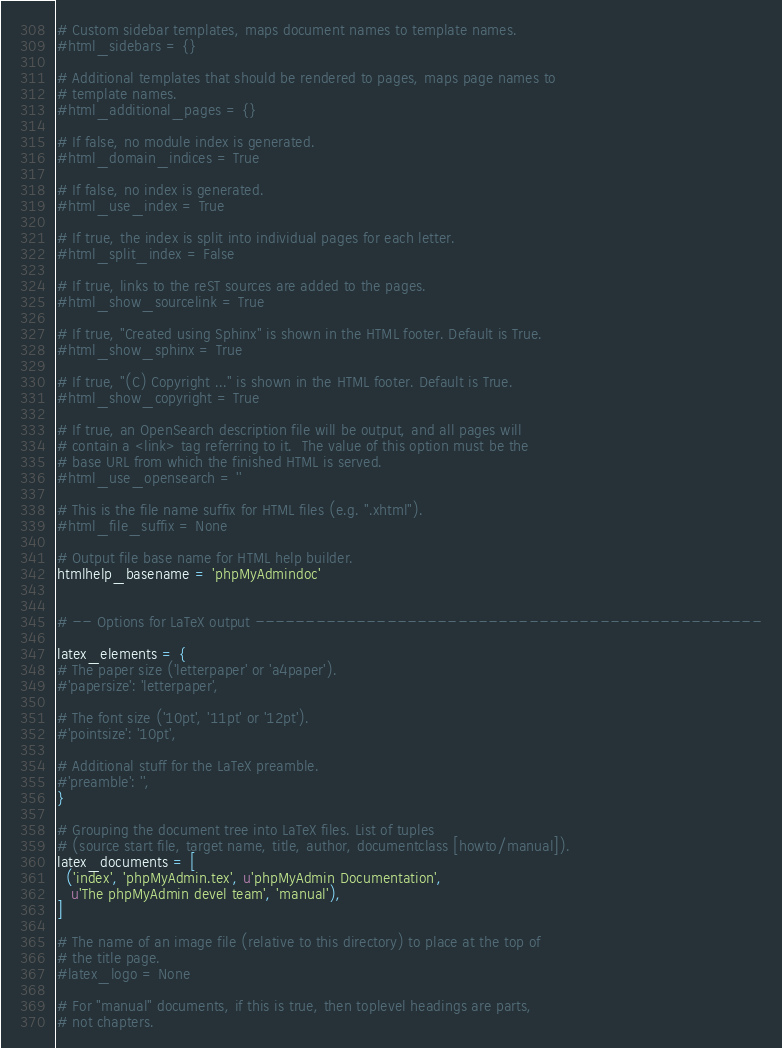Convert code to text. <code><loc_0><loc_0><loc_500><loc_500><_Python_># Custom sidebar templates, maps document names to template names.
#html_sidebars = {}

# Additional templates that should be rendered to pages, maps page names to
# template names.
#html_additional_pages = {}

# If false, no module index is generated.
#html_domain_indices = True

# If false, no index is generated.
#html_use_index = True

# If true, the index is split into individual pages for each letter.
#html_split_index = False

# If true, links to the reST sources are added to the pages.
#html_show_sourcelink = True

# If true, "Created using Sphinx" is shown in the HTML footer. Default is True.
#html_show_sphinx = True

# If true, "(C) Copyright ..." is shown in the HTML footer. Default is True.
#html_show_copyright = True

# If true, an OpenSearch description file will be output, and all pages will
# contain a <link> tag referring to it.  The value of this option must be the
# base URL from which the finished HTML is served.
#html_use_opensearch = ''

# This is the file name suffix for HTML files (e.g. ".xhtml").
#html_file_suffix = None

# Output file base name for HTML help builder.
htmlhelp_basename = 'phpMyAdmindoc'


# -- Options for LaTeX output --------------------------------------------------

latex_elements = {
# The paper size ('letterpaper' or 'a4paper').
#'papersize': 'letterpaper',

# The font size ('10pt', '11pt' or '12pt').
#'pointsize': '10pt',

# Additional stuff for the LaTeX preamble.
#'preamble': '',
}

# Grouping the document tree into LaTeX files. List of tuples
# (source start file, target name, title, author, documentclass [howto/manual]).
latex_documents = [
  ('index', 'phpMyAdmin.tex', u'phpMyAdmin Documentation',
   u'The phpMyAdmin devel team', 'manual'),
]

# The name of an image file (relative to this directory) to place at the top of
# the title page.
#latex_logo = None

# For "manual" documents, if this is true, then toplevel headings are parts,
# not chapters.</code> 